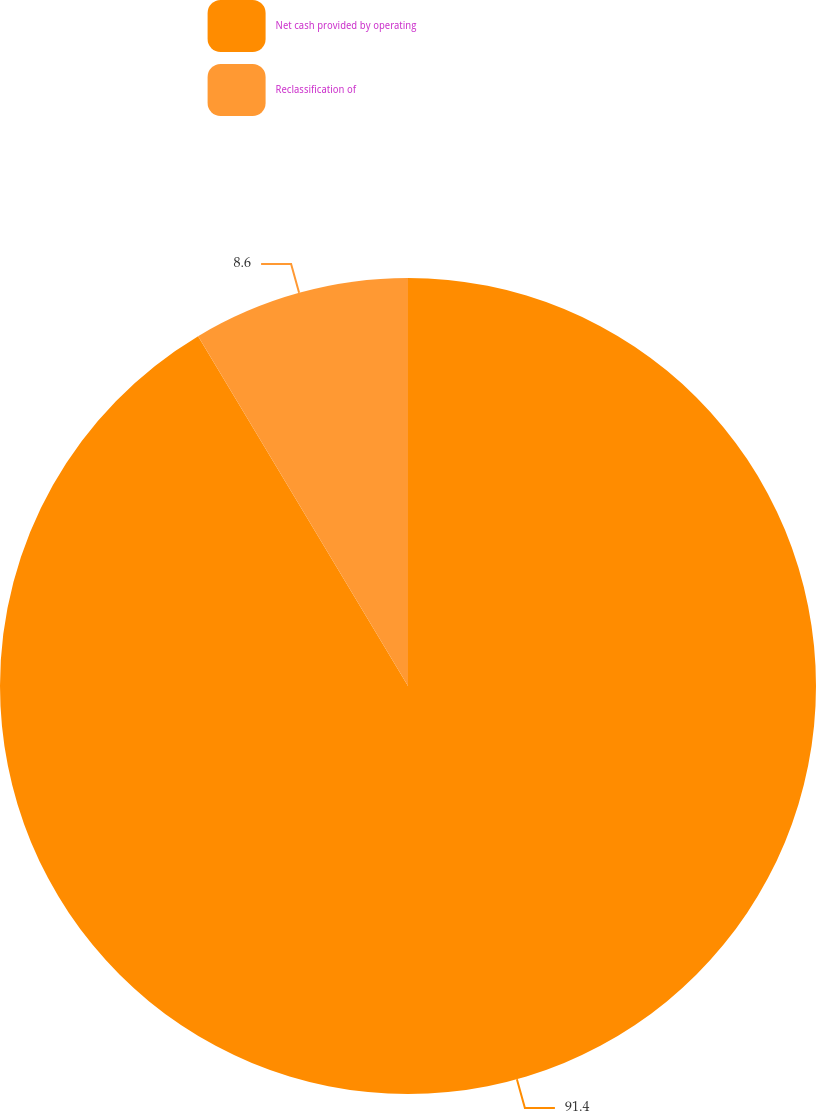Convert chart to OTSL. <chart><loc_0><loc_0><loc_500><loc_500><pie_chart><fcel>Net cash provided by operating<fcel>Reclassification of<nl><fcel>91.4%<fcel>8.6%<nl></chart> 